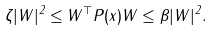<formula> <loc_0><loc_0><loc_500><loc_500>\zeta | W | ^ { 2 } \leq W ^ { \top } P ( x ) W \leq \beta | W | ^ { 2 } .</formula> 